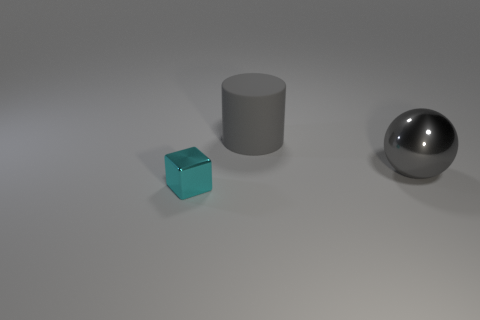Are there any other things that are the same shape as the large gray shiny thing?
Ensure brevity in your answer.  No. How many cyan things are the same material as the cylinder?
Your response must be concise. 0. The metallic object that is behind the cyan block has what shape?
Your answer should be very brief. Sphere. Is the material of the cyan thing the same as the large gray object behind the gray sphere?
Your response must be concise. No. Are there any large cyan balls?
Offer a very short reply. No. Is there a tiny shiny object that is in front of the big thing that is behind the gray object on the right side of the large rubber cylinder?
Your answer should be compact. Yes. How many large things are either green cylinders or blocks?
Offer a very short reply. 0. There is another thing that is the same size as the gray metal object; what color is it?
Make the answer very short. Gray. How many large gray spheres are left of the large metal sphere?
Keep it short and to the point. 0. Is there a green cylinder made of the same material as the block?
Your answer should be compact. No. 